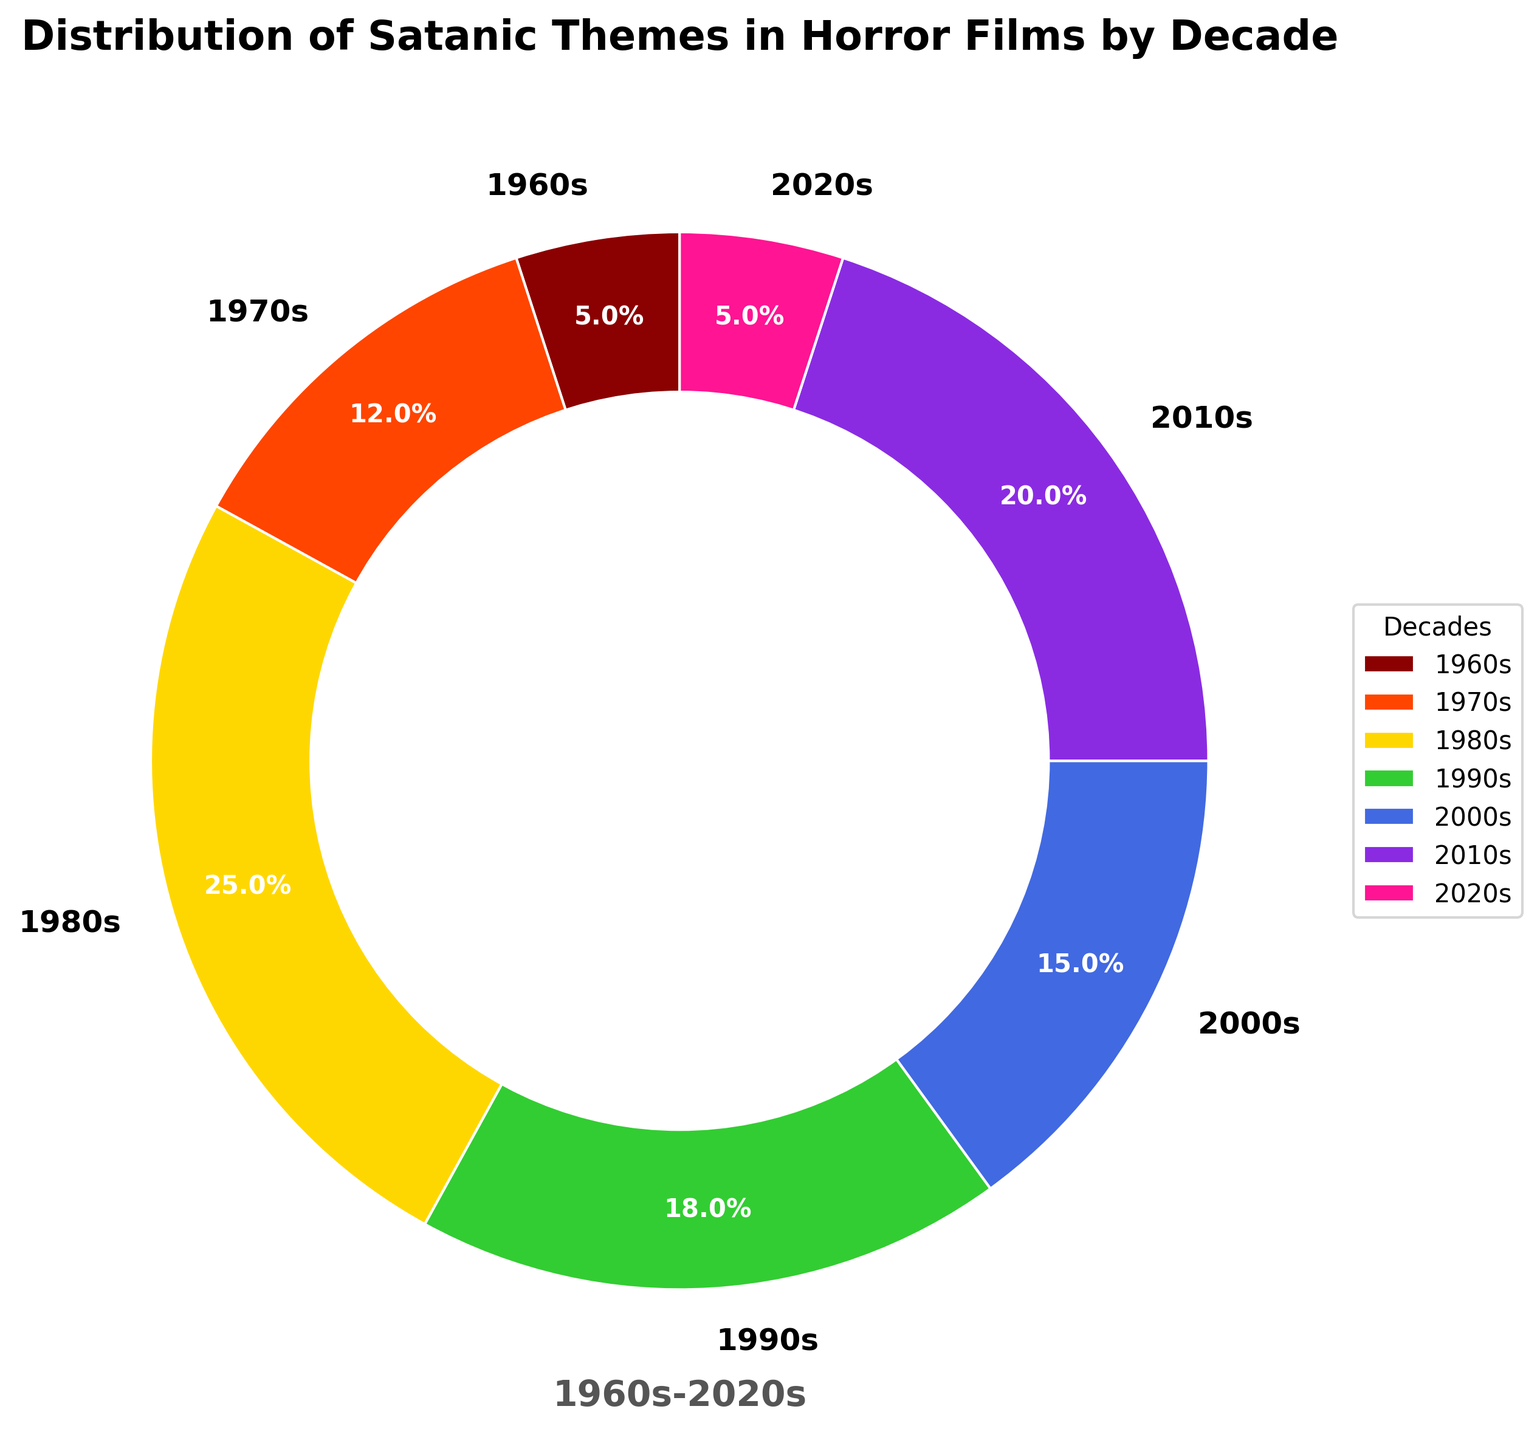Which decade has the highest percentage of satanic themes in horror films? By looking at the pie chart, the 1980s section is the largest, indicating the highest percentage.
Answer: 1980s What is the combined percentage of satanic themes in horror films for the decades 2000s and 2010s? Add the percentages for the 2000s (15%) and 2010s (20%). 15 + 20 = 35.
Answer: 35% How does the percentage of satanic themes in horror films in the 2020s compare to that in the 1960s? The pie chart shows that both the 1960s and 2020s have the same percentage of satanic themes, which is 5%.
Answer: They are equal Which decade saw a decrease in the percentage of satanic themes compared to the previous decade? Compare each decade's percentage to the previous one: the 1990s (18%) had a lower percentage than the 1980s (25%).
Answer: 1990s Identify the decade that had the second lowest percentage of satanic themes in horror films. By excluding the lowest percentage first (both 1960s and 2020s at 5%), the next smallest slice is the 1970s with 12%.
Answer: 1970s Which color represents the decade with the third highest percentage of satanic themes in horror films? The third highest percentage is the 2000s with 15%, which is colored green on the chart.
Answer: Green 